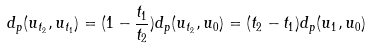<formula> <loc_0><loc_0><loc_500><loc_500>d _ { p } ( u _ { t _ { 2 } } , u _ { t _ { 1 } } ) = ( 1 - \frac { t _ { 1 } } { t _ { 2 } } ) d _ { p } ( u _ { t _ { 2 } } , u _ { 0 } ) = ( t _ { 2 } - t _ { 1 } ) d _ { p } ( u _ { 1 } , u _ { 0 } )</formula> 